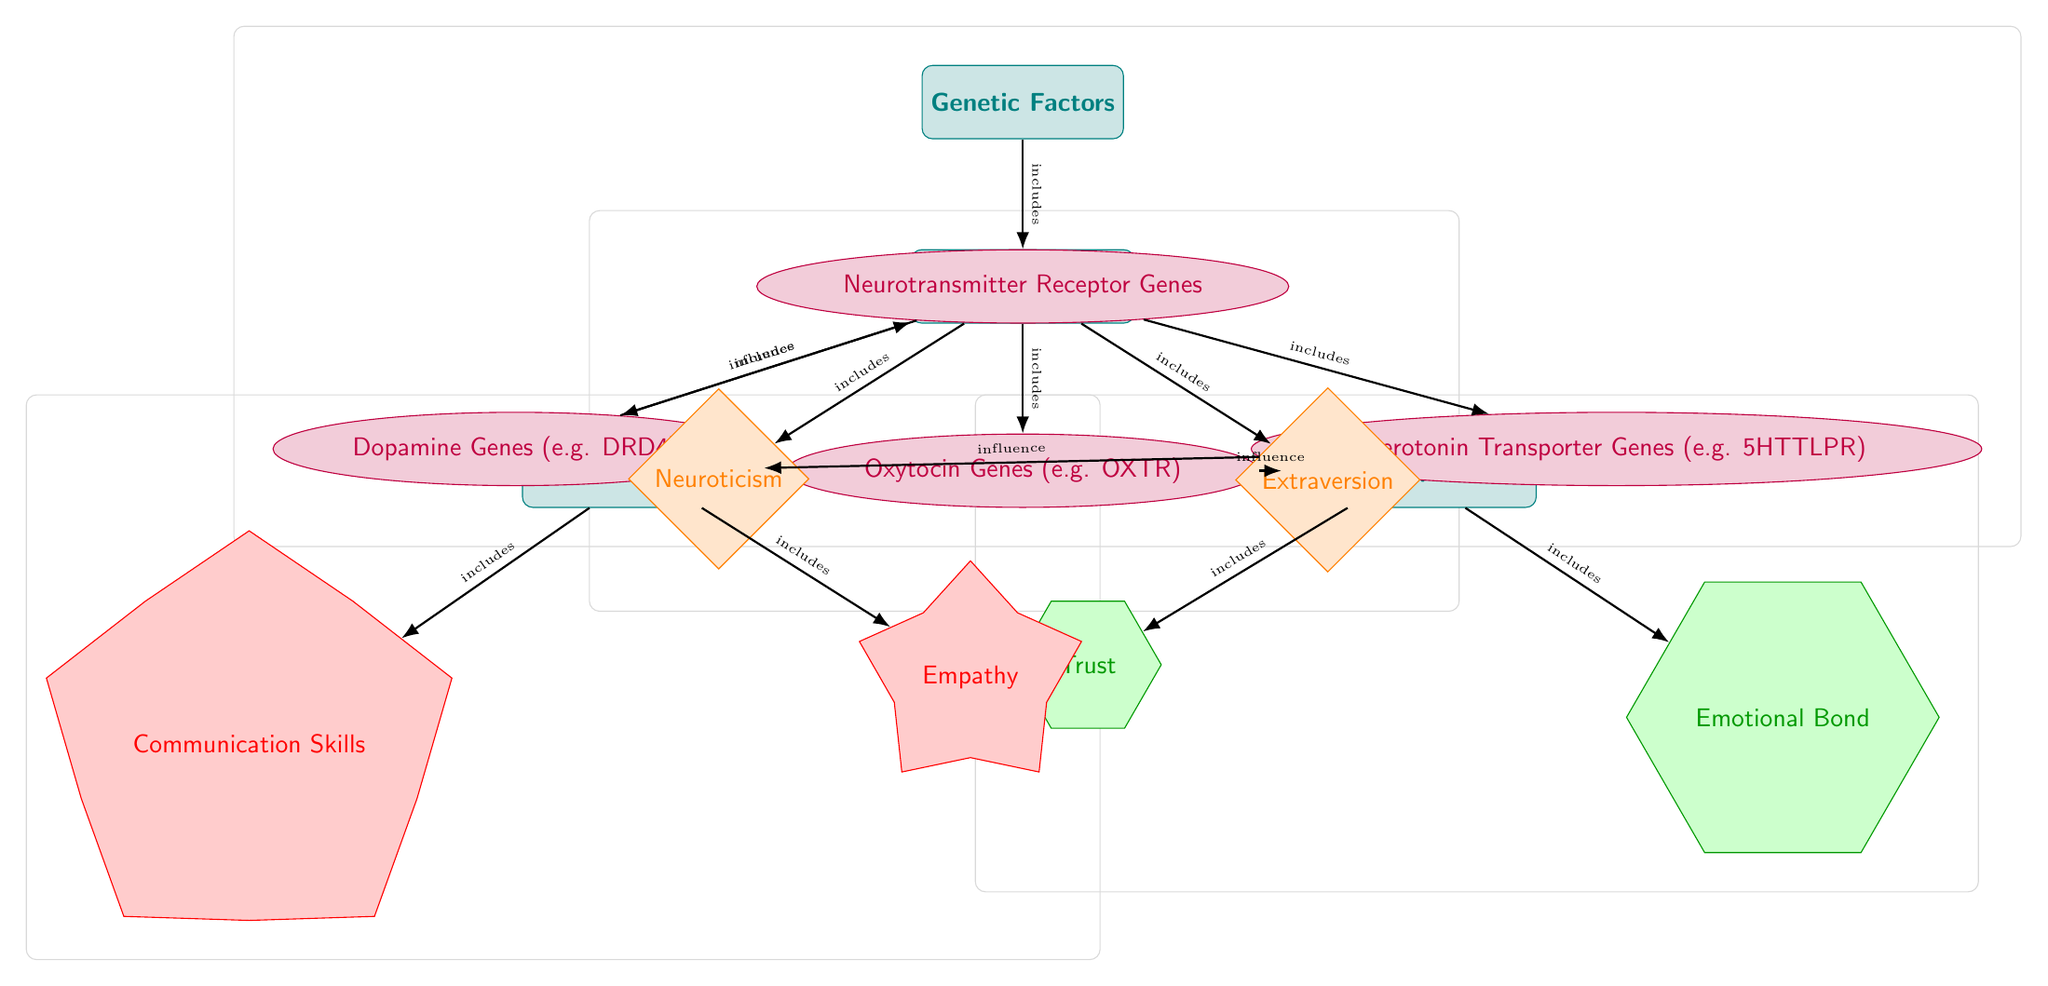What are the genetic factors included in this diagram? The diagram lists Neurotransmitter Receptor Genes, Dopamine Genes, Oxytocin Genes, and Serotonin Transporter Genes as components of Genetic Factors.
Answer: Neurotransmitter Receptor Genes, Dopamine Genes, Oxytocin Genes, Serotonin Transporter Genes Which personality traits are affected according to the diagram? The personality traits shown in the diagram are Neuroticism and Extraversion, which are included under Personality Traits.
Answer: Neuroticism, Extraversion How many edges connect personality traits to conflict resolution? There is one edge in the diagram that directly connects Personality Traits to Conflict Resolution, indicating their relationship.
Answer: 1 What influences Relationship Quality in the diagram? The diagram indicates that Oxytocin Genes influence Relationship Quality, demonstrating a link between genetics and relationship aspects.
Answer: Oxytocin Genes Which genetic factor influences conflict resolution? The diagram shows that Serotonin Transporter Genes influence conflict resolution, highlighting their impact on this area of relationships.
Answer: Serotonin Transporter Genes What types of qualities are included under Relationship Quality? The qualities listed under Relationship Quality in the diagram are Trust and Emotional Bond, which are essential components of a healthy relationship.
Answer: Trust, Emotional Bond How many genetic factors are identified in the diagram? The diagram identifies four genetic factors under the Genetic Factors category, specifically through the Neurotransmitter Receptor Genes node.
Answer: 4 What relationship is depicted between Dopamine Genes and Personality Traits? The diagram illustrates that Dopamine Genes influence Personality Traits, indicating a connection between genetic predispositions and individual characteristics.
Answer: influence What is the connection between Communication Skills and Conflict Resolution? The diagram shows that Communication Skills are included in Conflict Resolution, suggesting that effective communication is a vital part of resolving disputes.
Answer: includes 